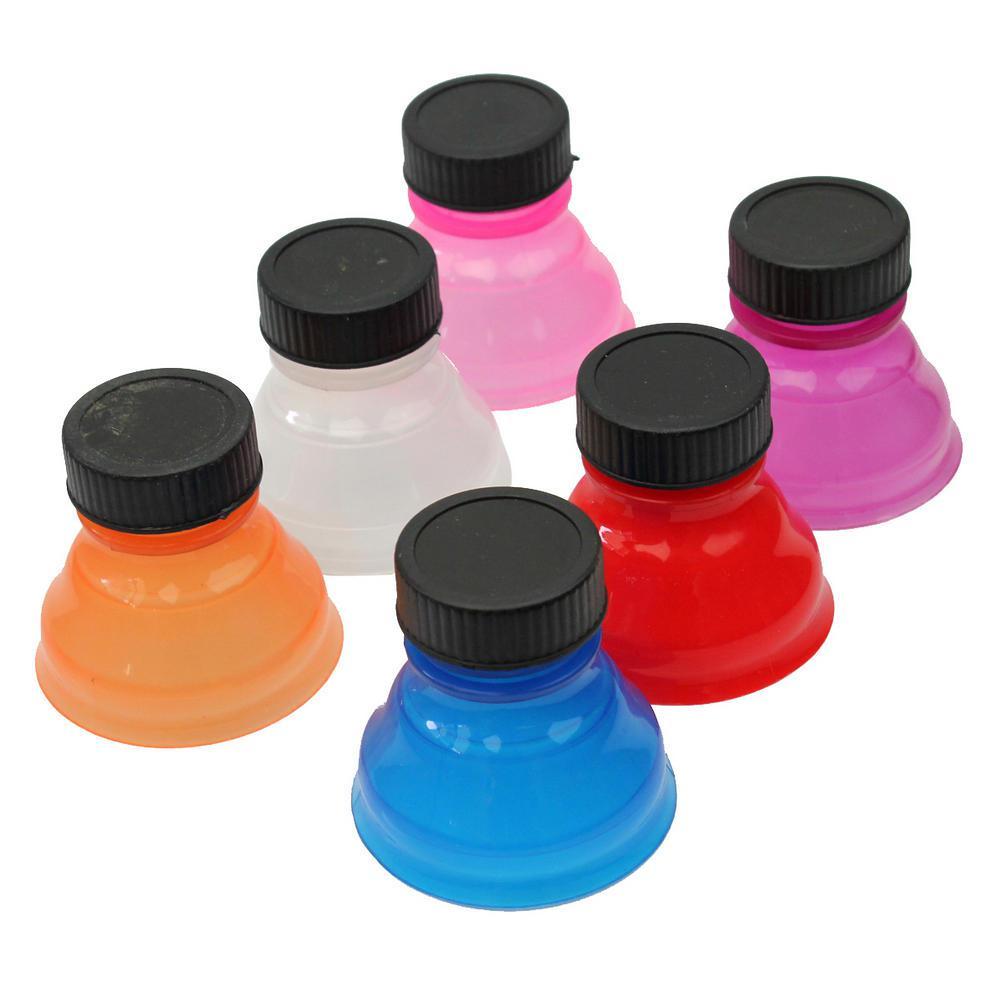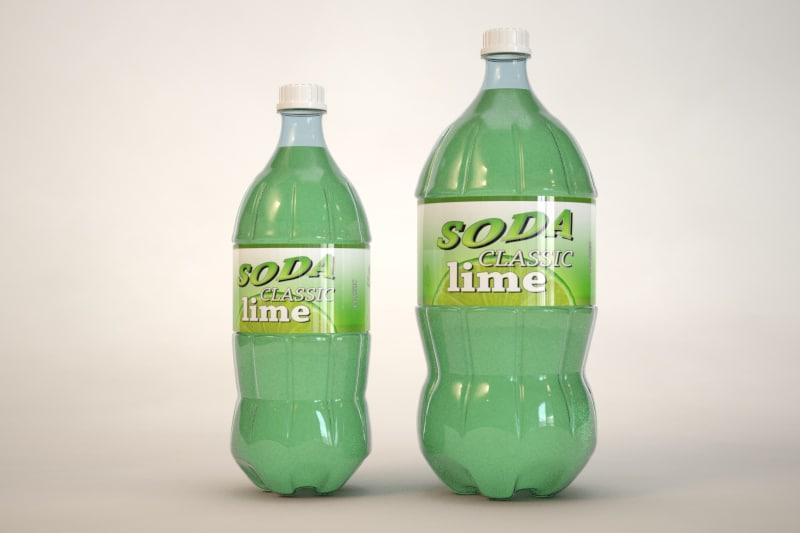The first image is the image on the left, the second image is the image on the right. Given the left and right images, does the statement "There are no more than 3 bottles in the image on the left." hold true? Answer yes or no. No. The first image is the image on the left, the second image is the image on the right. Considering the images on both sides, is "All bottles contain colored liquids and have labels and caps on." valid? Answer yes or no. No. 